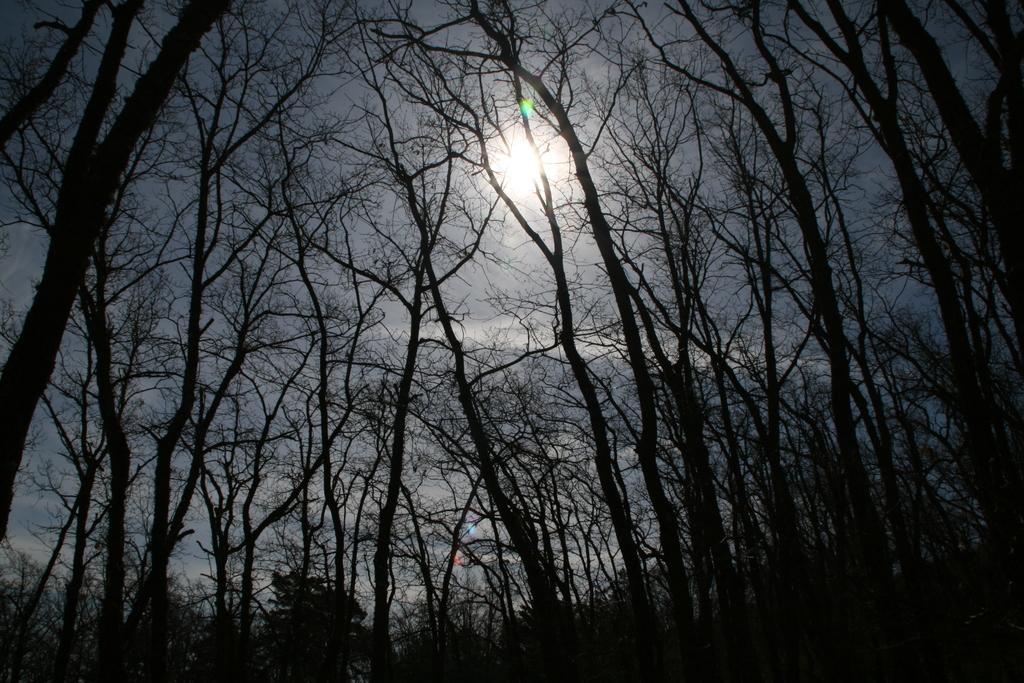In one or two sentences, can you explain what this image depicts? In the picture we can see many trees and behind it we can see a sky with sun. 